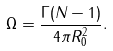<formula> <loc_0><loc_0><loc_500><loc_500>\Omega = \frac { \Gamma ( N - 1 ) } { 4 \pi R _ { 0 } ^ { 2 } } .</formula> 